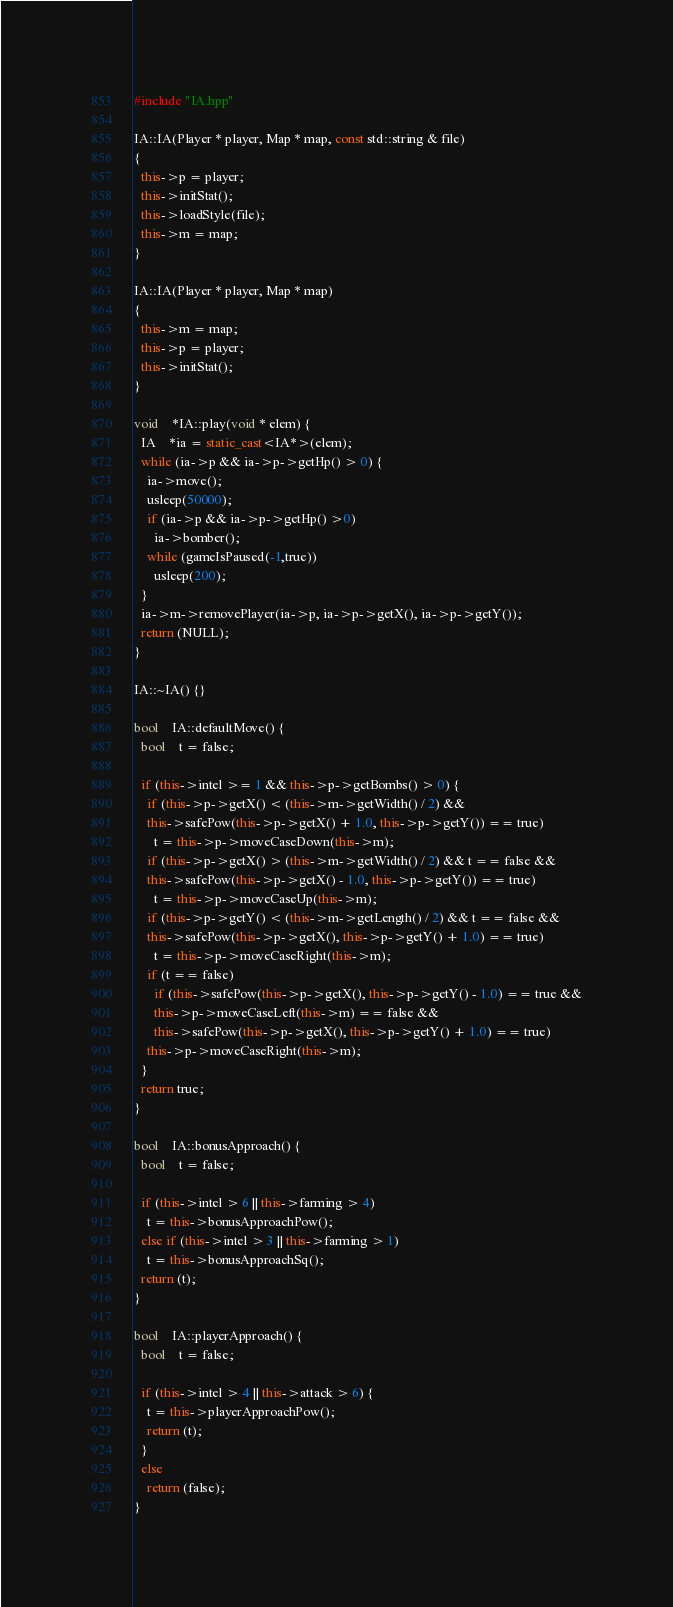<code> <loc_0><loc_0><loc_500><loc_500><_C++_>
#include "IA.hpp"

IA::IA(Player * player, Map * map, const std::string & file)
{
  this->p = player;
  this->initStat();
  this->loadStyle(file);
  this->m = map;
}

IA::IA(Player * player, Map * map)
{
  this->m = map;
  this->p = player;
  this->initStat();
}

void	*IA::play(void * elem) {
  IA	*ia = static_cast<IA*>(elem);
  while (ia->p && ia->p->getHp() > 0) {
    ia->move();
    usleep(50000);
    if (ia->p && ia->p->getHp() >0)
      ia->bomber();
    while (gameIsPaused(-1,true))
      usleep(200);
  }
  ia->m->removePlayer(ia->p, ia->p->getX(), ia->p->getY());
  return (NULL);
}

IA::~IA() {}

bool	IA::defaultMove() {
  bool	t = false;

  if (this->intel >= 1 && this->p->getBombs() > 0) {
    if (this->p->getX() < (this->m->getWidth() / 2) &&
	this->safePow(this->p->getX() + 1.0, this->p->getY()) == true)
      t = this->p->moveCaseDown(this->m);
    if (this->p->getX() > (this->m->getWidth() / 2) && t == false &&
	this->safePow(this->p->getX() - 1.0, this->p->getY()) == true)
      t = this->p->moveCaseUp(this->m);
    if (this->p->getY() < (this->m->getLength() / 2) && t == false &&
	this->safePow(this->p->getX(), this->p->getY() + 1.0) == true)
      t = this->p->moveCaseRight(this->m);
    if (t == false)
      if (this->safePow(this->p->getX(), this->p->getY() - 1.0) == true &&
	  this->p->moveCaseLeft(this->m) == false &&
	  this->safePow(this->p->getX(), this->p->getY() + 1.0) == true)
	this->p->moveCaseRight(this->m);
  }
  return true;
}

bool	IA::bonusApproach() {
  bool	t = false;

  if (this->intel > 6 || this->farming > 4)
    t = this->bonusApproachPow();
  else if (this->intel > 3 || this->farming > 1)
    t = this->bonusApproachSq();
  return (t);
}

bool	IA::playerApproach() {
  bool	t = false;

  if (this->intel > 4 || this->attack > 6) {
    t = this->playerApproachPow();
    return (t);
  }
  else
    return (false);
}
</code> 